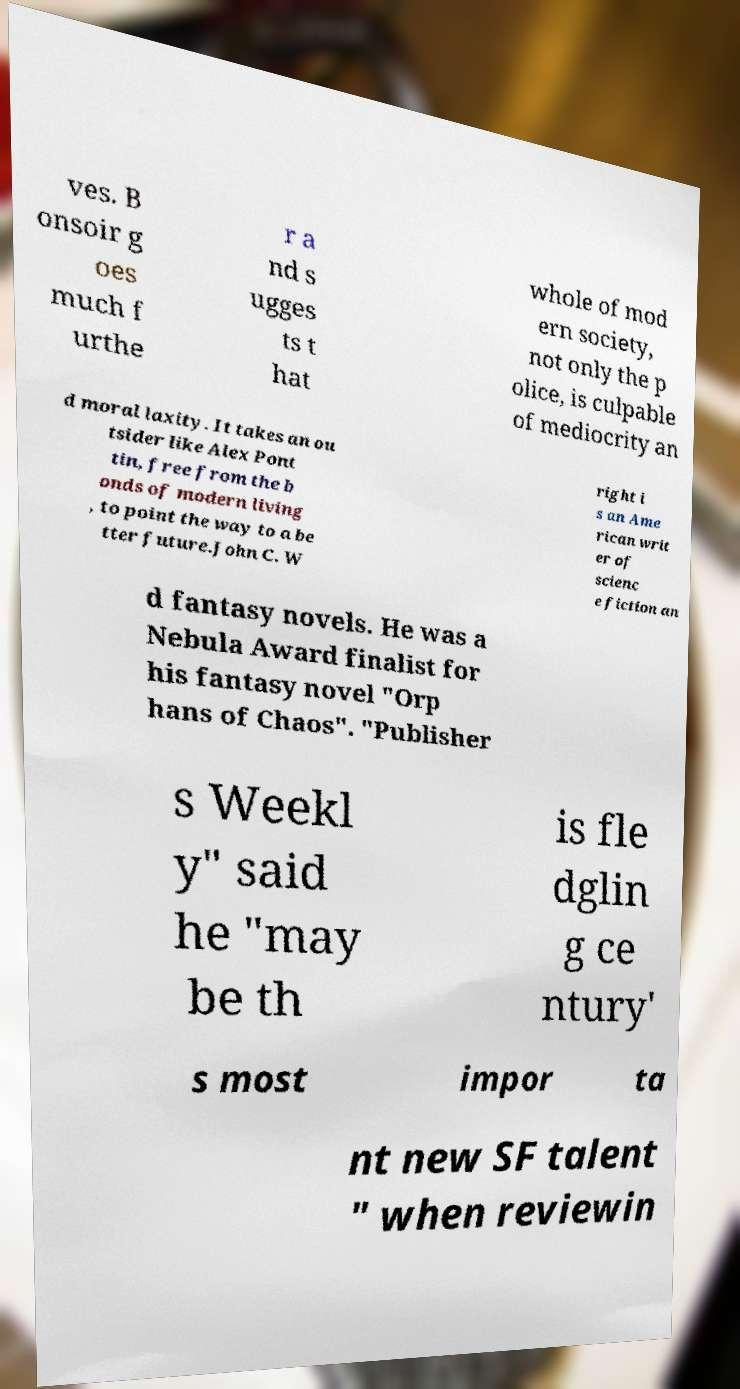Please read and relay the text visible in this image. What does it say? ves. B onsoir g oes much f urthe r a nd s ugges ts t hat whole of mod ern society, not only the p olice, is culpable of mediocrity an d moral laxity. It takes an ou tsider like Alex Pont tin, free from the b onds of modern living , to point the way to a be tter future.John C. W right i s an Ame rican writ er of scienc e fiction an d fantasy novels. He was a Nebula Award finalist for his fantasy novel "Orp hans of Chaos". "Publisher s Weekl y" said he "may be th is fle dglin g ce ntury' s most impor ta nt new SF talent " when reviewin 